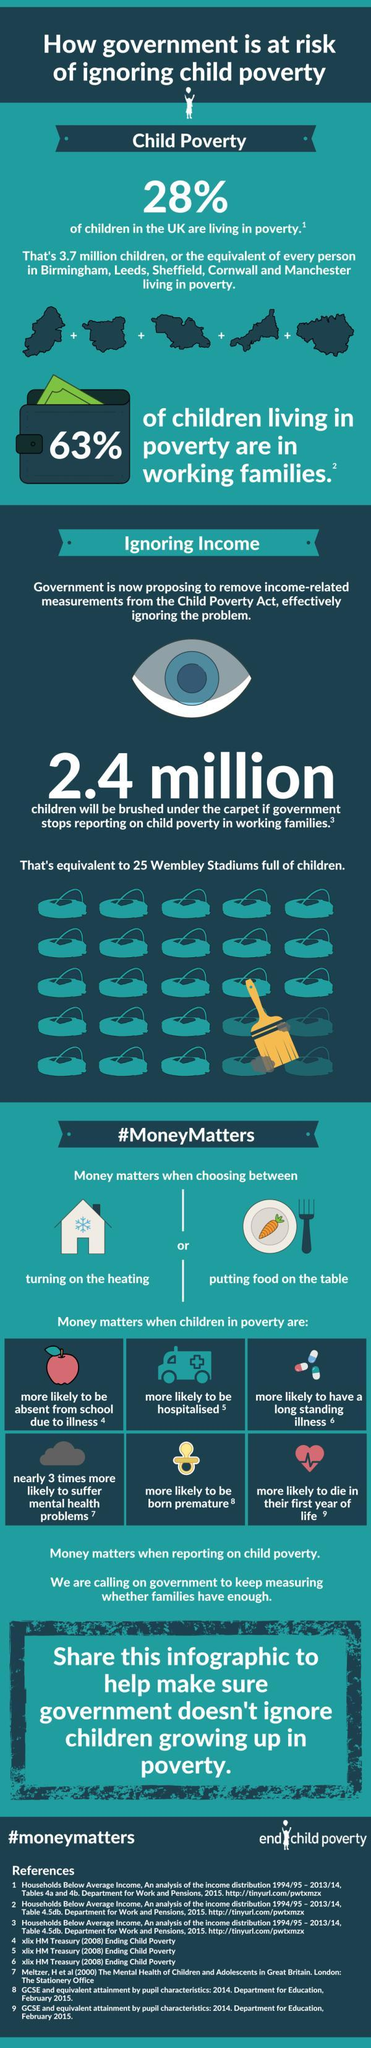What is the hashtag used to end child poverty?
Answer the question with a short phrase. #moneymatters What percent of children living in poverty come from workless families? 37% What percent of children in UK are not living in poverty? 72% 